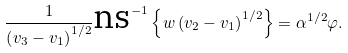<formula> <loc_0><loc_0><loc_500><loc_500>\frac { 1 } { \left ( v _ { 3 } - v _ { 1 } \right ) ^ { 1 / 2 } } \text {ns} ^ { - 1 } \left \{ w \left ( v _ { 2 } - v _ { 1 } \right ) ^ { 1 / 2 } \right \} = \alpha ^ { 1 / 2 } \varphi .</formula> 